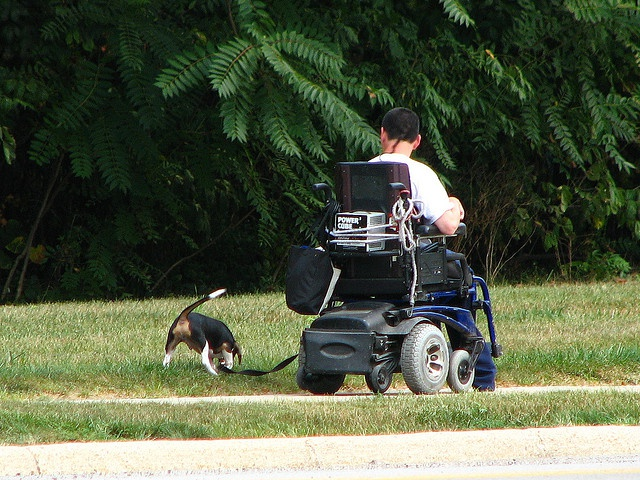Describe the objects in this image and their specific colors. I can see chair in black, gray, darkgray, and lightgray tones, people in black, white, lightpink, and tan tones, handbag in black, darkgray, lightgray, and gray tones, and dog in black, gray, white, and maroon tones in this image. 